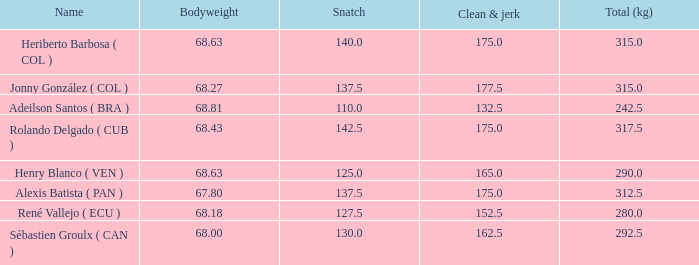Could you help me parse every detail presented in this table? {'header': ['Name', 'Bodyweight', 'Snatch', 'Clean & jerk', 'Total (kg)'], 'rows': [['Heriberto Barbosa ( COL )', '68.63', '140.0', '175.0', '315.0'], ['Jonny González ( COL )', '68.27', '137.5', '177.5', '315.0'], ['Adeilson Santos ( BRA )', '68.81', '110.0', '132.5', '242.5'], ['Rolando Delgado ( CUB )', '68.43', '142.5', '175.0', '317.5'], ['Henry Blanco ( VEN )', '68.63', '125.0', '165.0', '290.0'], ['Alexis Batista ( PAN )', '67.80', '137.5', '175.0', '312.5'], ['René Vallejo ( ECU )', '68.18', '127.5', '152.5', '280.0'], ['Sébastien Groulx ( CAN )', '68.00', '130.0', '162.5', '292.5']]} Tell me the highest snatch for 68.63 bodyweight and total kg less than 290 None. 